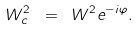<formula> <loc_0><loc_0><loc_500><loc_500>W ^ { 2 } _ { c } \ = \ W ^ { 2 } e ^ { - i \varphi } .</formula> 